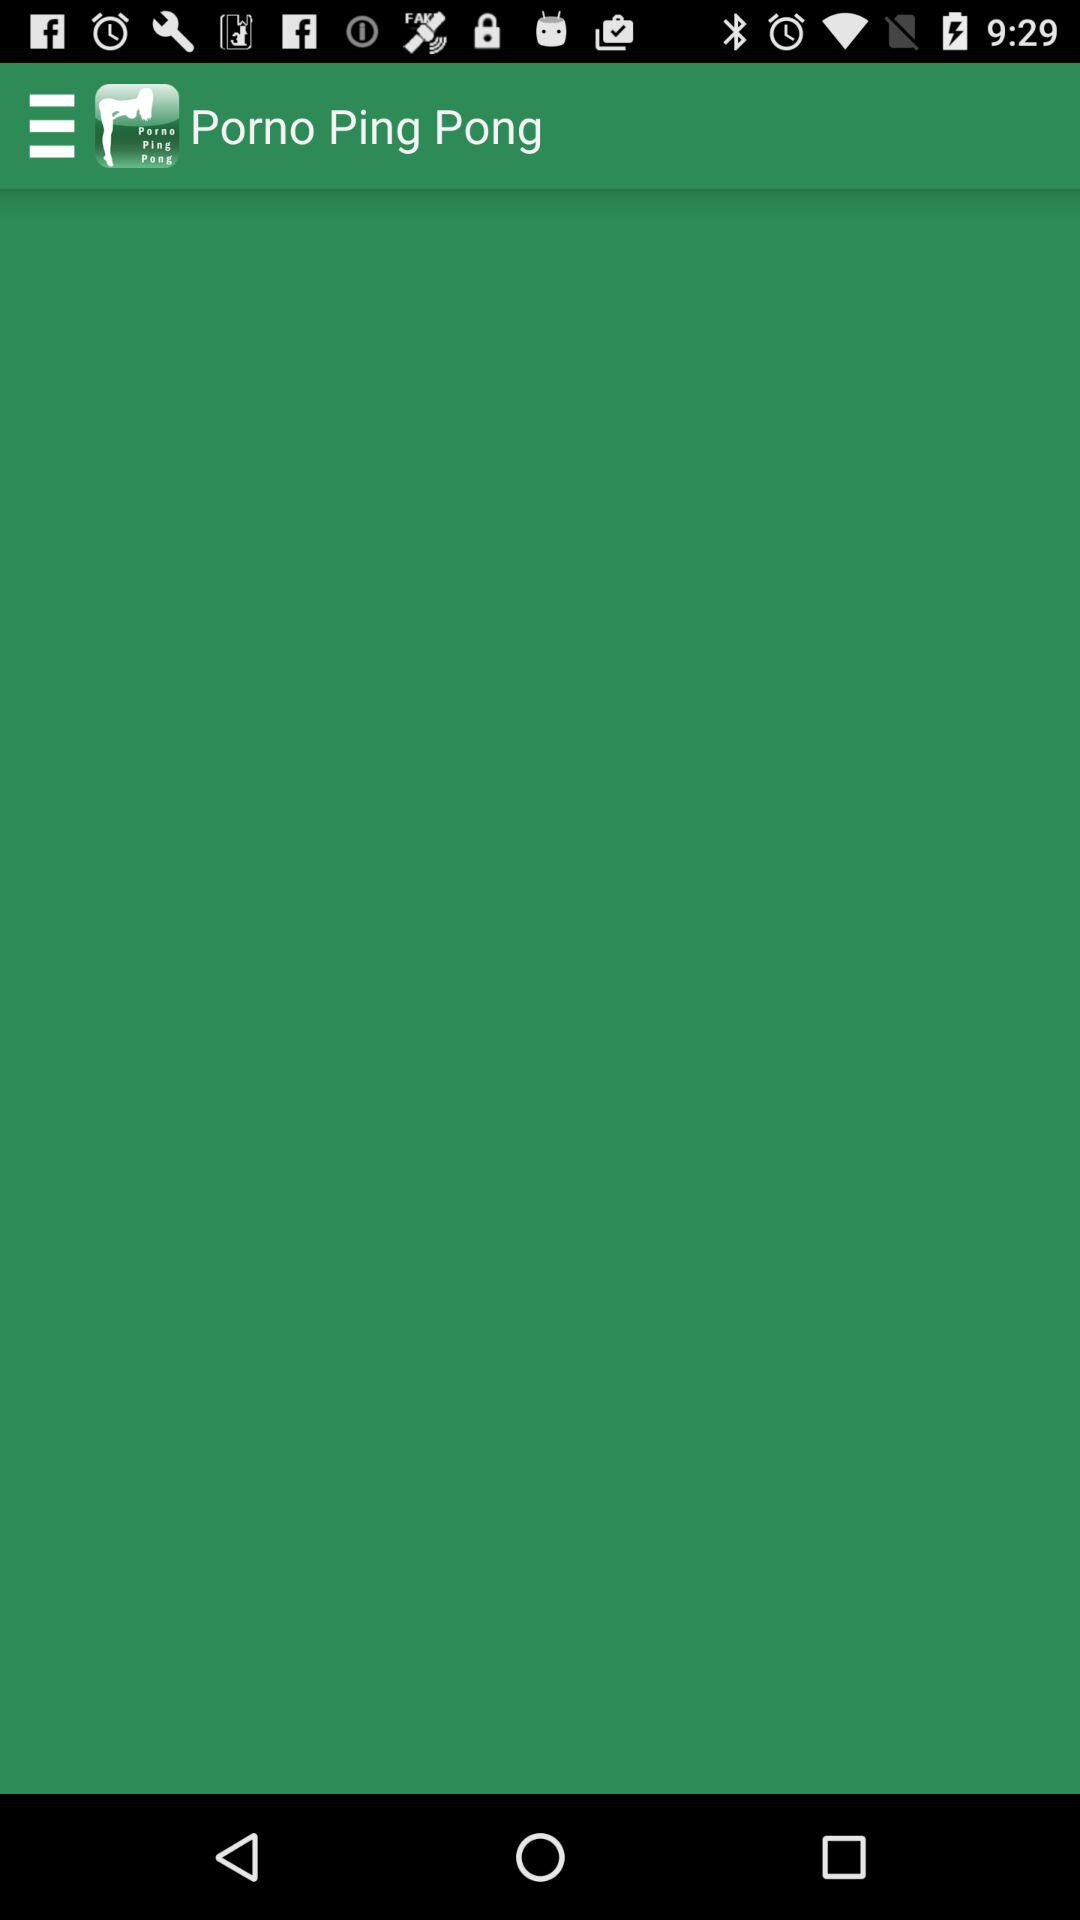What is the app name? The app name is "Porno Ping Pong". 